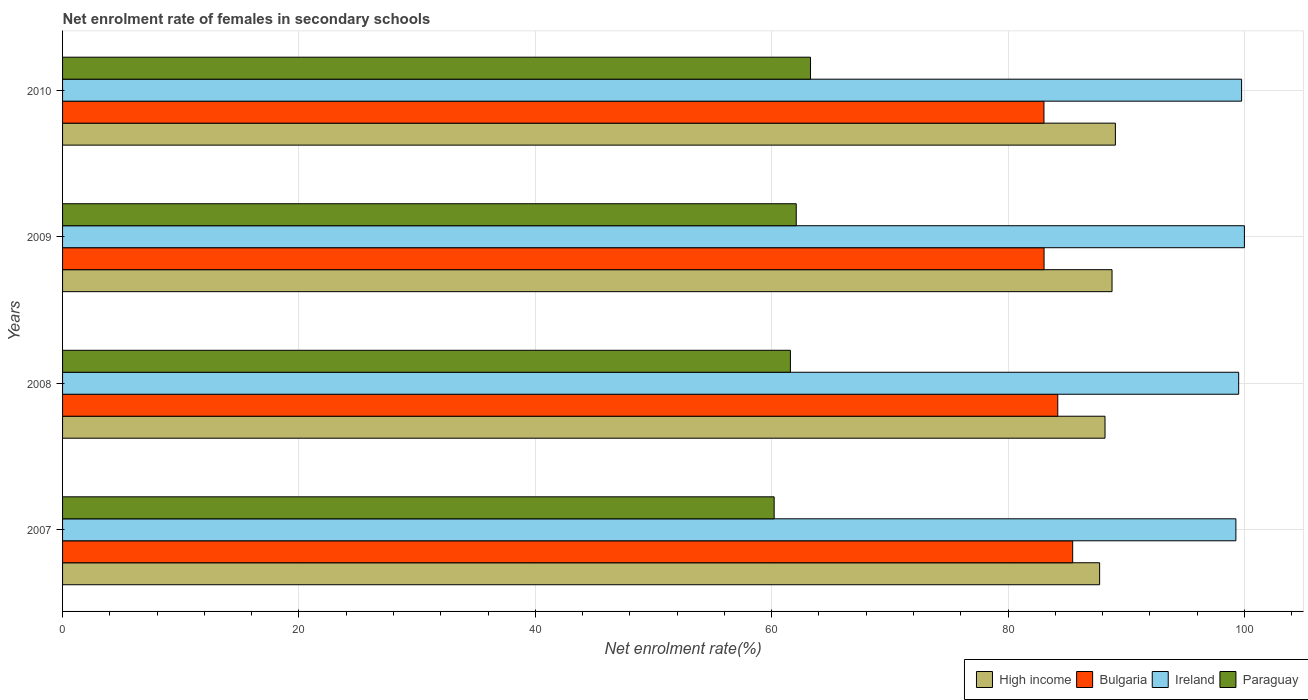How many groups of bars are there?
Your answer should be compact. 4. Are the number of bars per tick equal to the number of legend labels?
Offer a very short reply. Yes. Are the number of bars on each tick of the Y-axis equal?
Your answer should be very brief. Yes. How many bars are there on the 1st tick from the top?
Your response must be concise. 4. What is the label of the 1st group of bars from the top?
Offer a terse response. 2010. In how many cases, is the number of bars for a given year not equal to the number of legend labels?
Provide a short and direct response. 0. What is the net enrolment rate of females in secondary schools in Paraguay in 2010?
Offer a very short reply. 63.29. Across all years, what is the minimum net enrolment rate of females in secondary schools in High income?
Your answer should be very brief. 87.75. In which year was the net enrolment rate of females in secondary schools in Bulgaria maximum?
Your answer should be compact. 2007. What is the total net enrolment rate of females in secondary schools in High income in the graph?
Provide a short and direct response. 353.84. What is the difference between the net enrolment rate of females in secondary schools in Bulgaria in 2009 and that in 2010?
Give a very brief answer. 0.01. What is the difference between the net enrolment rate of females in secondary schools in Paraguay in 2010 and the net enrolment rate of females in secondary schools in Bulgaria in 2007?
Keep it short and to the point. -22.18. What is the average net enrolment rate of females in secondary schools in Paraguay per year?
Keep it short and to the point. 61.79. In the year 2007, what is the difference between the net enrolment rate of females in secondary schools in Bulgaria and net enrolment rate of females in secondary schools in High income?
Your answer should be compact. -2.28. In how many years, is the net enrolment rate of females in secondary schools in Bulgaria greater than 8 %?
Give a very brief answer. 4. What is the ratio of the net enrolment rate of females in secondary schools in High income in 2007 to that in 2010?
Your response must be concise. 0.99. What is the difference between the highest and the second highest net enrolment rate of females in secondary schools in Bulgaria?
Provide a succinct answer. 1.26. What is the difference between the highest and the lowest net enrolment rate of females in secondary schools in Paraguay?
Keep it short and to the point. 3.08. In how many years, is the net enrolment rate of females in secondary schools in Paraguay greater than the average net enrolment rate of females in secondary schools in Paraguay taken over all years?
Your answer should be compact. 2. Is it the case that in every year, the sum of the net enrolment rate of females in secondary schools in Paraguay and net enrolment rate of females in secondary schools in Ireland is greater than the sum of net enrolment rate of females in secondary schools in Bulgaria and net enrolment rate of females in secondary schools in High income?
Provide a succinct answer. No. What does the 3rd bar from the bottom in 2010 represents?
Offer a very short reply. Ireland. Are all the bars in the graph horizontal?
Keep it short and to the point. Yes. What is the difference between two consecutive major ticks on the X-axis?
Make the answer very short. 20. Does the graph contain grids?
Offer a terse response. Yes. What is the title of the graph?
Provide a succinct answer. Net enrolment rate of females in secondary schools. What is the label or title of the X-axis?
Give a very brief answer. Net enrolment rate(%). What is the Net enrolment rate(%) of High income in 2007?
Your answer should be compact. 87.75. What is the Net enrolment rate(%) in Bulgaria in 2007?
Your answer should be very brief. 85.47. What is the Net enrolment rate(%) in Ireland in 2007?
Provide a succinct answer. 99.28. What is the Net enrolment rate(%) in Paraguay in 2007?
Make the answer very short. 60.21. What is the Net enrolment rate(%) of High income in 2008?
Provide a succinct answer. 88.21. What is the Net enrolment rate(%) in Bulgaria in 2008?
Give a very brief answer. 84.21. What is the Net enrolment rate(%) of Ireland in 2008?
Provide a succinct answer. 99.52. What is the Net enrolment rate(%) of Paraguay in 2008?
Your answer should be very brief. 61.59. What is the Net enrolment rate(%) in High income in 2009?
Ensure brevity in your answer.  88.8. What is the Net enrolment rate(%) of Bulgaria in 2009?
Give a very brief answer. 83.05. What is the Net enrolment rate(%) in Paraguay in 2009?
Your response must be concise. 62.08. What is the Net enrolment rate(%) of High income in 2010?
Make the answer very short. 89.08. What is the Net enrolment rate(%) of Bulgaria in 2010?
Ensure brevity in your answer.  83.04. What is the Net enrolment rate(%) of Ireland in 2010?
Provide a succinct answer. 99.76. What is the Net enrolment rate(%) of Paraguay in 2010?
Offer a terse response. 63.29. Across all years, what is the maximum Net enrolment rate(%) in High income?
Keep it short and to the point. 89.08. Across all years, what is the maximum Net enrolment rate(%) in Bulgaria?
Your answer should be very brief. 85.47. Across all years, what is the maximum Net enrolment rate(%) of Paraguay?
Your response must be concise. 63.29. Across all years, what is the minimum Net enrolment rate(%) in High income?
Ensure brevity in your answer.  87.75. Across all years, what is the minimum Net enrolment rate(%) in Bulgaria?
Offer a terse response. 83.04. Across all years, what is the minimum Net enrolment rate(%) of Ireland?
Make the answer very short. 99.28. Across all years, what is the minimum Net enrolment rate(%) of Paraguay?
Provide a short and direct response. 60.21. What is the total Net enrolment rate(%) of High income in the graph?
Your answer should be compact. 353.84. What is the total Net enrolment rate(%) in Bulgaria in the graph?
Give a very brief answer. 335.76. What is the total Net enrolment rate(%) of Ireland in the graph?
Give a very brief answer. 398.56. What is the total Net enrolment rate(%) in Paraguay in the graph?
Your response must be concise. 247.16. What is the difference between the Net enrolment rate(%) of High income in 2007 and that in 2008?
Offer a very short reply. -0.46. What is the difference between the Net enrolment rate(%) in Bulgaria in 2007 and that in 2008?
Offer a terse response. 1.26. What is the difference between the Net enrolment rate(%) in Ireland in 2007 and that in 2008?
Offer a terse response. -0.24. What is the difference between the Net enrolment rate(%) in Paraguay in 2007 and that in 2008?
Provide a short and direct response. -1.38. What is the difference between the Net enrolment rate(%) in High income in 2007 and that in 2009?
Ensure brevity in your answer.  -1.05. What is the difference between the Net enrolment rate(%) in Bulgaria in 2007 and that in 2009?
Offer a terse response. 2.42. What is the difference between the Net enrolment rate(%) in Ireland in 2007 and that in 2009?
Ensure brevity in your answer.  -0.72. What is the difference between the Net enrolment rate(%) in Paraguay in 2007 and that in 2009?
Keep it short and to the point. -1.87. What is the difference between the Net enrolment rate(%) of High income in 2007 and that in 2010?
Give a very brief answer. -1.33. What is the difference between the Net enrolment rate(%) of Bulgaria in 2007 and that in 2010?
Ensure brevity in your answer.  2.43. What is the difference between the Net enrolment rate(%) in Ireland in 2007 and that in 2010?
Your answer should be very brief. -0.48. What is the difference between the Net enrolment rate(%) of Paraguay in 2007 and that in 2010?
Your answer should be very brief. -3.08. What is the difference between the Net enrolment rate(%) in High income in 2008 and that in 2009?
Your answer should be compact. -0.59. What is the difference between the Net enrolment rate(%) in Bulgaria in 2008 and that in 2009?
Offer a terse response. 1.16. What is the difference between the Net enrolment rate(%) of Ireland in 2008 and that in 2009?
Make the answer very short. -0.48. What is the difference between the Net enrolment rate(%) in Paraguay in 2008 and that in 2009?
Make the answer very short. -0.49. What is the difference between the Net enrolment rate(%) of High income in 2008 and that in 2010?
Offer a terse response. -0.88. What is the difference between the Net enrolment rate(%) of Bulgaria in 2008 and that in 2010?
Offer a very short reply. 1.17. What is the difference between the Net enrolment rate(%) in Ireland in 2008 and that in 2010?
Your response must be concise. -0.25. What is the difference between the Net enrolment rate(%) of Paraguay in 2008 and that in 2010?
Make the answer very short. -1.7. What is the difference between the Net enrolment rate(%) in High income in 2009 and that in 2010?
Provide a short and direct response. -0.28. What is the difference between the Net enrolment rate(%) in Bulgaria in 2009 and that in 2010?
Your answer should be compact. 0.01. What is the difference between the Net enrolment rate(%) of Ireland in 2009 and that in 2010?
Ensure brevity in your answer.  0.24. What is the difference between the Net enrolment rate(%) of Paraguay in 2009 and that in 2010?
Provide a succinct answer. -1.21. What is the difference between the Net enrolment rate(%) of High income in 2007 and the Net enrolment rate(%) of Bulgaria in 2008?
Provide a short and direct response. 3.54. What is the difference between the Net enrolment rate(%) of High income in 2007 and the Net enrolment rate(%) of Ireland in 2008?
Your answer should be compact. -11.77. What is the difference between the Net enrolment rate(%) of High income in 2007 and the Net enrolment rate(%) of Paraguay in 2008?
Make the answer very short. 26.16. What is the difference between the Net enrolment rate(%) in Bulgaria in 2007 and the Net enrolment rate(%) in Ireland in 2008?
Your answer should be compact. -14.05. What is the difference between the Net enrolment rate(%) of Bulgaria in 2007 and the Net enrolment rate(%) of Paraguay in 2008?
Your response must be concise. 23.88. What is the difference between the Net enrolment rate(%) of Ireland in 2007 and the Net enrolment rate(%) of Paraguay in 2008?
Your response must be concise. 37.69. What is the difference between the Net enrolment rate(%) of High income in 2007 and the Net enrolment rate(%) of Bulgaria in 2009?
Your answer should be compact. 4.7. What is the difference between the Net enrolment rate(%) in High income in 2007 and the Net enrolment rate(%) in Ireland in 2009?
Ensure brevity in your answer.  -12.25. What is the difference between the Net enrolment rate(%) in High income in 2007 and the Net enrolment rate(%) in Paraguay in 2009?
Provide a short and direct response. 25.67. What is the difference between the Net enrolment rate(%) in Bulgaria in 2007 and the Net enrolment rate(%) in Ireland in 2009?
Your answer should be very brief. -14.53. What is the difference between the Net enrolment rate(%) in Bulgaria in 2007 and the Net enrolment rate(%) in Paraguay in 2009?
Offer a terse response. 23.39. What is the difference between the Net enrolment rate(%) of Ireland in 2007 and the Net enrolment rate(%) of Paraguay in 2009?
Your answer should be compact. 37.2. What is the difference between the Net enrolment rate(%) in High income in 2007 and the Net enrolment rate(%) in Bulgaria in 2010?
Offer a terse response. 4.71. What is the difference between the Net enrolment rate(%) of High income in 2007 and the Net enrolment rate(%) of Ireland in 2010?
Make the answer very short. -12.01. What is the difference between the Net enrolment rate(%) of High income in 2007 and the Net enrolment rate(%) of Paraguay in 2010?
Your answer should be compact. 24.46. What is the difference between the Net enrolment rate(%) of Bulgaria in 2007 and the Net enrolment rate(%) of Ireland in 2010?
Ensure brevity in your answer.  -14.29. What is the difference between the Net enrolment rate(%) in Bulgaria in 2007 and the Net enrolment rate(%) in Paraguay in 2010?
Offer a terse response. 22.18. What is the difference between the Net enrolment rate(%) of Ireland in 2007 and the Net enrolment rate(%) of Paraguay in 2010?
Keep it short and to the point. 35.99. What is the difference between the Net enrolment rate(%) in High income in 2008 and the Net enrolment rate(%) in Bulgaria in 2009?
Keep it short and to the point. 5.16. What is the difference between the Net enrolment rate(%) in High income in 2008 and the Net enrolment rate(%) in Ireland in 2009?
Make the answer very short. -11.79. What is the difference between the Net enrolment rate(%) of High income in 2008 and the Net enrolment rate(%) of Paraguay in 2009?
Ensure brevity in your answer.  26.13. What is the difference between the Net enrolment rate(%) in Bulgaria in 2008 and the Net enrolment rate(%) in Ireland in 2009?
Offer a terse response. -15.79. What is the difference between the Net enrolment rate(%) in Bulgaria in 2008 and the Net enrolment rate(%) in Paraguay in 2009?
Offer a very short reply. 22.13. What is the difference between the Net enrolment rate(%) of Ireland in 2008 and the Net enrolment rate(%) of Paraguay in 2009?
Provide a succinct answer. 37.44. What is the difference between the Net enrolment rate(%) in High income in 2008 and the Net enrolment rate(%) in Bulgaria in 2010?
Keep it short and to the point. 5.17. What is the difference between the Net enrolment rate(%) of High income in 2008 and the Net enrolment rate(%) of Ireland in 2010?
Give a very brief answer. -11.56. What is the difference between the Net enrolment rate(%) of High income in 2008 and the Net enrolment rate(%) of Paraguay in 2010?
Provide a succinct answer. 24.92. What is the difference between the Net enrolment rate(%) in Bulgaria in 2008 and the Net enrolment rate(%) in Ireland in 2010?
Your answer should be compact. -15.56. What is the difference between the Net enrolment rate(%) of Bulgaria in 2008 and the Net enrolment rate(%) of Paraguay in 2010?
Your response must be concise. 20.92. What is the difference between the Net enrolment rate(%) in Ireland in 2008 and the Net enrolment rate(%) in Paraguay in 2010?
Your answer should be compact. 36.23. What is the difference between the Net enrolment rate(%) of High income in 2009 and the Net enrolment rate(%) of Bulgaria in 2010?
Provide a short and direct response. 5.76. What is the difference between the Net enrolment rate(%) in High income in 2009 and the Net enrolment rate(%) in Ireland in 2010?
Give a very brief answer. -10.96. What is the difference between the Net enrolment rate(%) of High income in 2009 and the Net enrolment rate(%) of Paraguay in 2010?
Your answer should be compact. 25.51. What is the difference between the Net enrolment rate(%) in Bulgaria in 2009 and the Net enrolment rate(%) in Ireland in 2010?
Your answer should be very brief. -16.71. What is the difference between the Net enrolment rate(%) of Bulgaria in 2009 and the Net enrolment rate(%) of Paraguay in 2010?
Your answer should be very brief. 19.76. What is the difference between the Net enrolment rate(%) in Ireland in 2009 and the Net enrolment rate(%) in Paraguay in 2010?
Provide a succinct answer. 36.71. What is the average Net enrolment rate(%) in High income per year?
Provide a short and direct response. 88.46. What is the average Net enrolment rate(%) in Bulgaria per year?
Keep it short and to the point. 83.94. What is the average Net enrolment rate(%) in Ireland per year?
Ensure brevity in your answer.  99.64. What is the average Net enrolment rate(%) of Paraguay per year?
Provide a short and direct response. 61.79. In the year 2007, what is the difference between the Net enrolment rate(%) of High income and Net enrolment rate(%) of Bulgaria?
Give a very brief answer. 2.28. In the year 2007, what is the difference between the Net enrolment rate(%) in High income and Net enrolment rate(%) in Ireland?
Offer a terse response. -11.53. In the year 2007, what is the difference between the Net enrolment rate(%) in High income and Net enrolment rate(%) in Paraguay?
Provide a succinct answer. 27.54. In the year 2007, what is the difference between the Net enrolment rate(%) in Bulgaria and Net enrolment rate(%) in Ireland?
Give a very brief answer. -13.81. In the year 2007, what is the difference between the Net enrolment rate(%) of Bulgaria and Net enrolment rate(%) of Paraguay?
Provide a succinct answer. 25.26. In the year 2007, what is the difference between the Net enrolment rate(%) of Ireland and Net enrolment rate(%) of Paraguay?
Your response must be concise. 39.07. In the year 2008, what is the difference between the Net enrolment rate(%) in High income and Net enrolment rate(%) in Bulgaria?
Offer a terse response. 4. In the year 2008, what is the difference between the Net enrolment rate(%) in High income and Net enrolment rate(%) in Ireland?
Ensure brevity in your answer.  -11.31. In the year 2008, what is the difference between the Net enrolment rate(%) in High income and Net enrolment rate(%) in Paraguay?
Ensure brevity in your answer.  26.62. In the year 2008, what is the difference between the Net enrolment rate(%) of Bulgaria and Net enrolment rate(%) of Ireland?
Your response must be concise. -15.31. In the year 2008, what is the difference between the Net enrolment rate(%) in Bulgaria and Net enrolment rate(%) in Paraguay?
Provide a short and direct response. 22.62. In the year 2008, what is the difference between the Net enrolment rate(%) of Ireland and Net enrolment rate(%) of Paraguay?
Provide a short and direct response. 37.93. In the year 2009, what is the difference between the Net enrolment rate(%) of High income and Net enrolment rate(%) of Bulgaria?
Make the answer very short. 5.75. In the year 2009, what is the difference between the Net enrolment rate(%) of High income and Net enrolment rate(%) of Ireland?
Offer a terse response. -11.2. In the year 2009, what is the difference between the Net enrolment rate(%) in High income and Net enrolment rate(%) in Paraguay?
Keep it short and to the point. 26.72. In the year 2009, what is the difference between the Net enrolment rate(%) in Bulgaria and Net enrolment rate(%) in Ireland?
Keep it short and to the point. -16.95. In the year 2009, what is the difference between the Net enrolment rate(%) of Bulgaria and Net enrolment rate(%) of Paraguay?
Provide a short and direct response. 20.97. In the year 2009, what is the difference between the Net enrolment rate(%) in Ireland and Net enrolment rate(%) in Paraguay?
Your answer should be very brief. 37.92. In the year 2010, what is the difference between the Net enrolment rate(%) in High income and Net enrolment rate(%) in Bulgaria?
Make the answer very short. 6.05. In the year 2010, what is the difference between the Net enrolment rate(%) in High income and Net enrolment rate(%) in Ireland?
Ensure brevity in your answer.  -10.68. In the year 2010, what is the difference between the Net enrolment rate(%) of High income and Net enrolment rate(%) of Paraguay?
Ensure brevity in your answer.  25.8. In the year 2010, what is the difference between the Net enrolment rate(%) in Bulgaria and Net enrolment rate(%) in Ireland?
Provide a succinct answer. -16.72. In the year 2010, what is the difference between the Net enrolment rate(%) in Bulgaria and Net enrolment rate(%) in Paraguay?
Offer a very short reply. 19.75. In the year 2010, what is the difference between the Net enrolment rate(%) in Ireland and Net enrolment rate(%) in Paraguay?
Provide a short and direct response. 36.48. What is the ratio of the Net enrolment rate(%) in Paraguay in 2007 to that in 2008?
Make the answer very short. 0.98. What is the ratio of the Net enrolment rate(%) in Bulgaria in 2007 to that in 2009?
Offer a terse response. 1.03. What is the ratio of the Net enrolment rate(%) in Ireland in 2007 to that in 2009?
Make the answer very short. 0.99. What is the ratio of the Net enrolment rate(%) of Paraguay in 2007 to that in 2009?
Offer a very short reply. 0.97. What is the ratio of the Net enrolment rate(%) of Bulgaria in 2007 to that in 2010?
Provide a short and direct response. 1.03. What is the ratio of the Net enrolment rate(%) in Ireland in 2007 to that in 2010?
Give a very brief answer. 1. What is the ratio of the Net enrolment rate(%) in Paraguay in 2007 to that in 2010?
Keep it short and to the point. 0.95. What is the ratio of the Net enrolment rate(%) of High income in 2008 to that in 2009?
Keep it short and to the point. 0.99. What is the ratio of the Net enrolment rate(%) of Bulgaria in 2008 to that in 2009?
Offer a very short reply. 1.01. What is the ratio of the Net enrolment rate(%) in Ireland in 2008 to that in 2009?
Offer a very short reply. 1. What is the ratio of the Net enrolment rate(%) of High income in 2008 to that in 2010?
Make the answer very short. 0.99. What is the ratio of the Net enrolment rate(%) in Bulgaria in 2008 to that in 2010?
Give a very brief answer. 1.01. What is the ratio of the Net enrolment rate(%) of Ireland in 2008 to that in 2010?
Your response must be concise. 1. What is the ratio of the Net enrolment rate(%) of Paraguay in 2008 to that in 2010?
Keep it short and to the point. 0.97. What is the ratio of the Net enrolment rate(%) in Ireland in 2009 to that in 2010?
Provide a succinct answer. 1. What is the ratio of the Net enrolment rate(%) in Paraguay in 2009 to that in 2010?
Offer a terse response. 0.98. What is the difference between the highest and the second highest Net enrolment rate(%) in High income?
Keep it short and to the point. 0.28. What is the difference between the highest and the second highest Net enrolment rate(%) of Bulgaria?
Provide a short and direct response. 1.26. What is the difference between the highest and the second highest Net enrolment rate(%) of Ireland?
Offer a terse response. 0.24. What is the difference between the highest and the second highest Net enrolment rate(%) in Paraguay?
Ensure brevity in your answer.  1.21. What is the difference between the highest and the lowest Net enrolment rate(%) in High income?
Keep it short and to the point. 1.33. What is the difference between the highest and the lowest Net enrolment rate(%) of Bulgaria?
Make the answer very short. 2.43. What is the difference between the highest and the lowest Net enrolment rate(%) of Ireland?
Give a very brief answer. 0.72. What is the difference between the highest and the lowest Net enrolment rate(%) in Paraguay?
Offer a very short reply. 3.08. 